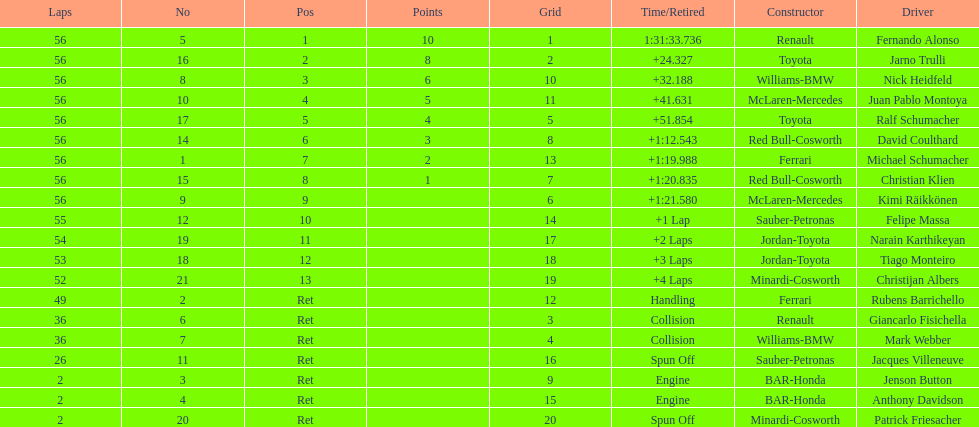How many drivers ended the race early because of engine problems? 2. 